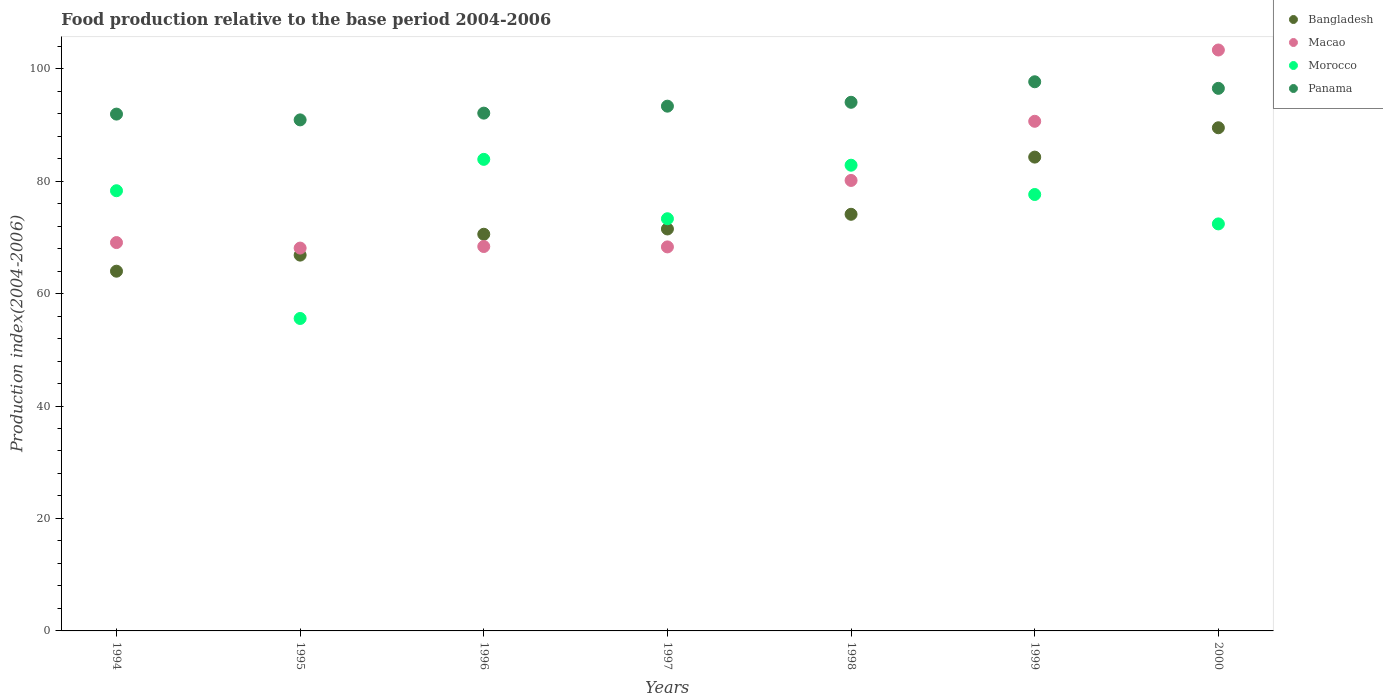What is the food production index in Panama in 1994?
Keep it short and to the point. 91.92. Across all years, what is the maximum food production index in Bangladesh?
Make the answer very short. 89.49. Across all years, what is the minimum food production index in Bangladesh?
Your answer should be compact. 63.98. In which year was the food production index in Morocco minimum?
Ensure brevity in your answer.  1995. What is the total food production index in Bangladesh in the graph?
Your response must be concise. 520.72. What is the difference between the food production index in Bangladesh in 1994 and that in 1997?
Keep it short and to the point. -7.51. What is the difference between the food production index in Bangladesh in 1998 and the food production index in Morocco in 1996?
Keep it short and to the point. -9.77. What is the average food production index in Morocco per year?
Make the answer very short. 74.84. In the year 1998, what is the difference between the food production index in Morocco and food production index in Bangladesh?
Ensure brevity in your answer.  8.73. What is the ratio of the food production index in Macao in 1996 to that in 1999?
Offer a very short reply. 0.75. Is the difference between the food production index in Morocco in 1998 and 1999 greater than the difference between the food production index in Bangladesh in 1998 and 1999?
Your answer should be compact. Yes. What is the difference between the highest and the second highest food production index in Bangladesh?
Ensure brevity in your answer.  5.22. What is the difference between the highest and the lowest food production index in Bangladesh?
Make the answer very short. 25.51. In how many years, is the food production index in Macao greater than the average food production index in Macao taken over all years?
Give a very brief answer. 3. Is the sum of the food production index in Panama in 1997 and 1999 greater than the maximum food production index in Morocco across all years?
Provide a succinct answer. Yes. Is it the case that in every year, the sum of the food production index in Bangladesh and food production index in Panama  is greater than the sum of food production index in Morocco and food production index in Macao?
Offer a terse response. No. Is the food production index in Morocco strictly greater than the food production index in Macao over the years?
Give a very brief answer. No. How many dotlines are there?
Provide a short and direct response. 4. What is the difference between two consecutive major ticks on the Y-axis?
Keep it short and to the point. 20. Does the graph contain any zero values?
Your answer should be compact. No. Does the graph contain grids?
Ensure brevity in your answer.  No. How are the legend labels stacked?
Make the answer very short. Vertical. What is the title of the graph?
Your answer should be compact. Food production relative to the base period 2004-2006. Does "Iceland" appear as one of the legend labels in the graph?
Give a very brief answer. No. What is the label or title of the Y-axis?
Ensure brevity in your answer.  Production index(2004-2006). What is the Production index(2004-2006) in Bangladesh in 1994?
Offer a very short reply. 63.98. What is the Production index(2004-2006) in Macao in 1994?
Offer a very short reply. 69.07. What is the Production index(2004-2006) in Morocco in 1994?
Provide a short and direct response. 78.29. What is the Production index(2004-2006) in Panama in 1994?
Provide a succinct answer. 91.92. What is the Production index(2004-2006) of Bangladesh in 1995?
Offer a terse response. 66.84. What is the Production index(2004-2006) of Macao in 1995?
Offer a terse response. 68.09. What is the Production index(2004-2006) in Morocco in 1995?
Your answer should be very brief. 55.57. What is the Production index(2004-2006) of Panama in 1995?
Ensure brevity in your answer.  90.89. What is the Production index(2004-2006) of Bangladesh in 1996?
Give a very brief answer. 70.55. What is the Production index(2004-2006) in Macao in 1996?
Keep it short and to the point. 68.37. What is the Production index(2004-2006) of Morocco in 1996?
Ensure brevity in your answer.  83.87. What is the Production index(2004-2006) of Panama in 1996?
Give a very brief answer. 92.09. What is the Production index(2004-2006) of Bangladesh in 1997?
Your answer should be compact. 71.49. What is the Production index(2004-2006) of Macao in 1997?
Your response must be concise. 68.3. What is the Production index(2004-2006) of Morocco in 1997?
Provide a succinct answer. 73.31. What is the Production index(2004-2006) in Panama in 1997?
Offer a terse response. 93.33. What is the Production index(2004-2006) in Bangladesh in 1998?
Make the answer very short. 74.1. What is the Production index(2004-2006) of Macao in 1998?
Offer a very short reply. 80.12. What is the Production index(2004-2006) in Morocco in 1998?
Provide a succinct answer. 82.83. What is the Production index(2004-2006) in Panama in 1998?
Your answer should be very brief. 94.02. What is the Production index(2004-2006) in Bangladesh in 1999?
Offer a terse response. 84.27. What is the Production index(2004-2006) of Macao in 1999?
Provide a succinct answer. 90.64. What is the Production index(2004-2006) of Morocco in 1999?
Keep it short and to the point. 77.62. What is the Production index(2004-2006) in Panama in 1999?
Offer a very short reply. 97.67. What is the Production index(2004-2006) of Bangladesh in 2000?
Offer a terse response. 89.49. What is the Production index(2004-2006) in Macao in 2000?
Your answer should be very brief. 103.32. What is the Production index(2004-2006) in Morocco in 2000?
Keep it short and to the point. 72.39. What is the Production index(2004-2006) in Panama in 2000?
Keep it short and to the point. 96.5. Across all years, what is the maximum Production index(2004-2006) of Bangladesh?
Keep it short and to the point. 89.49. Across all years, what is the maximum Production index(2004-2006) of Macao?
Provide a short and direct response. 103.32. Across all years, what is the maximum Production index(2004-2006) of Morocco?
Provide a short and direct response. 83.87. Across all years, what is the maximum Production index(2004-2006) of Panama?
Offer a terse response. 97.67. Across all years, what is the minimum Production index(2004-2006) in Bangladesh?
Offer a very short reply. 63.98. Across all years, what is the minimum Production index(2004-2006) in Macao?
Your answer should be compact. 68.09. Across all years, what is the minimum Production index(2004-2006) in Morocco?
Offer a terse response. 55.57. Across all years, what is the minimum Production index(2004-2006) of Panama?
Provide a succinct answer. 90.89. What is the total Production index(2004-2006) in Bangladesh in the graph?
Keep it short and to the point. 520.72. What is the total Production index(2004-2006) of Macao in the graph?
Your answer should be compact. 547.91. What is the total Production index(2004-2006) of Morocco in the graph?
Provide a short and direct response. 523.88. What is the total Production index(2004-2006) of Panama in the graph?
Your response must be concise. 656.42. What is the difference between the Production index(2004-2006) in Bangladesh in 1994 and that in 1995?
Your answer should be compact. -2.86. What is the difference between the Production index(2004-2006) of Macao in 1994 and that in 1995?
Offer a terse response. 0.98. What is the difference between the Production index(2004-2006) in Morocco in 1994 and that in 1995?
Offer a terse response. 22.72. What is the difference between the Production index(2004-2006) of Panama in 1994 and that in 1995?
Keep it short and to the point. 1.03. What is the difference between the Production index(2004-2006) of Bangladesh in 1994 and that in 1996?
Offer a terse response. -6.57. What is the difference between the Production index(2004-2006) in Macao in 1994 and that in 1996?
Make the answer very short. 0.7. What is the difference between the Production index(2004-2006) in Morocco in 1994 and that in 1996?
Your response must be concise. -5.58. What is the difference between the Production index(2004-2006) of Panama in 1994 and that in 1996?
Your response must be concise. -0.17. What is the difference between the Production index(2004-2006) of Bangladesh in 1994 and that in 1997?
Give a very brief answer. -7.51. What is the difference between the Production index(2004-2006) in Macao in 1994 and that in 1997?
Provide a short and direct response. 0.77. What is the difference between the Production index(2004-2006) of Morocco in 1994 and that in 1997?
Give a very brief answer. 4.98. What is the difference between the Production index(2004-2006) of Panama in 1994 and that in 1997?
Keep it short and to the point. -1.41. What is the difference between the Production index(2004-2006) of Bangladesh in 1994 and that in 1998?
Offer a very short reply. -10.12. What is the difference between the Production index(2004-2006) of Macao in 1994 and that in 1998?
Make the answer very short. -11.05. What is the difference between the Production index(2004-2006) in Morocco in 1994 and that in 1998?
Provide a short and direct response. -4.54. What is the difference between the Production index(2004-2006) in Bangladesh in 1994 and that in 1999?
Your answer should be very brief. -20.29. What is the difference between the Production index(2004-2006) of Macao in 1994 and that in 1999?
Make the answer very short. -21.57. What is the difference between the Production index(2004-2006) of Morocco in 1994 and that in 1999?
Your response must be concise. 0.67. What is the difference between the Production index(2004-2006) of Panama in 1994 and that in 1999?
Provide a succinct answer. -5.75. What is the difference between the Production index(2004-2006) of Bangladesh in 1994 and that in 2000?
Your answer should be very brief. -25.51. What is the difference between the Production index(2004-2006) of Macao in 1994 and that in 2000?
Give a very brief answer. -34.25. What is the difference between the Production index(2004-2006) of Panama in 1994 and that in 2000?
Your response must be concise. -4.58. What is the difference between the Production index(2004-2006) in Bangladesh in 1995 and that in 1996?
Your response must be concise. -3.71. What is the difference between the Production index(2004-2006) in Macao in 1995 and that in 1996?
Give a very brief answer. -0.28. What is the difference between the Production index(2004-2006) of Morocco in 1995 and that in 1996?
Offer a very short reply. -28.3. What is the difference between the Production index(2004-2006) of Panama in 1995 and that in 1996?
Provide a succinct answer. -1.2. What is the difference between the Production index(2004-2006) in Bangladesh in 1995 and that in 1997?
Keep it short and to the point. -4.65. What is the difference between the Production index(2004-2006) in Macao in 1995 and that in 1997?
Keep it short and to the point. -0.21. What is the difference between the Production index(2004-2006) in Morocco in 1995 and that in 1997?
Keep it short and to the point. -17.74. What is the difference between the Production index(2004-2006) of Panama in 1995 and that in 1997?
Provide a succinct answer. -2.44. What is the difference between the Production index(2004-2006) of Bangladesh in 1995 and that in 1998?
Offer a very short reply. -7.26. What is the difference between the Production index(2004-2006) in Macao in 1995 and that in 1998?
Provide a succinct answer. -12.03. What is the difference between the Production index(2004-2006) in Morocco in 1995 and that in 1998?
Your answer should be compact. -27.26. What is the difference between the Production index(2004-2006) of Panama in 1995 and that in 1998?
Your answer should be very brief. -3.13. What is the difference between the Production index(2004-2006) of Bangladesh in 1995 and that in 1999?
Ensure brevity in your answer.  -17.43. What is the difference between the Production index(2004-2006) of Macao in 1995 and that in 1999?
Your answer should be compact. -22.55. What is the difference between the Production index(2004-2006) of Morocco in 1995 and that in 1999?
Provide a short and direct response. -22.05. What is the difference between the Production index(2004-2006) in Panama in 1995 and that in 1999?
Provide a short and direct response. -6.78. What is the difference between the Production index(2004-2006) in Bangladesh in 1995 and that in 2000?
Ensure brevity in your answer.  -22.65. What is the difference between the Production index(2004-2006) of Macao in 1995 and that in 2000?
Your answer should be very brief. -35.23. What is the difference between the Production index(2004-2006) in Morocco in 1995 and that in 2000?
Offer a very short reply. -16.82. What is the difference between the Production index(2004-2006) in Panama in 1995 and that in 2000?
Your answer should be very brief. -5.61. What is the difference between the Production index(2004-2006) in Bangladesh in 1996 and that in 1997?
Offer a terse response. -0.94. What is the difference between the Production index(2004-2006) in Macao in 1996 and that in 1997?
Offer a very short reply. 0.07. What is the difference between the Production index(2004-2006) of Morocco in 1996 and that in 1997?
Provide a short and direct response. 10.56. What is the difference between the Production index(2004-2006) in Panama in 1996 and that in 1997?
Give a very brief answer. -1.24. What is the difference between the Production index(2004-2006) of Bangladesh in 1996 and that in 1998?
Give a very brief answer. -3.55. What is the difference between the Production index(2004-2006) in Macao in 1996 and that in 1998?
Ensure brevity in your answer.  -11.75. What is the difference between the Production index(2004-2006) in Morocco in 1996 and that in 1998?
Ensure brevity in your answer.  1.04. What is the difference between the Production index(2004-2006) of Panama in 1996 and that in 1998?
Give a very brief answer. -1.93. What is the difference between the Production index(2004-2006) of Bangladesh in 1996 and that in 1999?
Offer a very short reply. -13.72. What is the difference between the Production index(2004-2006) of Macao in 1996 and that in 1999?
Your answer should be very brief. -22.27. What is the difference between the Production index(2004-2006) in Morocco in 1996 and that in 1999?
Your response must be concise. 6.25. What is the difference between the Production index(2004-2006) of Panama in 1996 and that in 1999?
Ensure brevity in your answer.  -5.58. What is the difference between the Production index(2004-2006) in Bangladesh in 1996 and that in 2000?
Your response must be concise. -18.94. What is the difference between the Production index(2004-2006) of Macao in 1996 and that in 2000?
Offer a terse response. -34.95. What is the difference between the Production index(2004-2006) in Morocco in 1996 and that in 2000?
Keep it short and to the point. 11.48. What is the difference between the Production index(2004-2006) in Panama in 1996 and that in 2000?
Give a very brief answer. -4.41. What is the difference between the Production index(2004-2006) of Bangladesh in 1997 and that in 1998?
Provide a short and direct response. -2.61. What is the difference between the Production index(2004-2006) in Macao in 1997 and that in 1998?
Keep it short and to the point. -11.82. What is the difference between the Production index(2004-2006) of Morocco in 1997 and that in 1998?
Keep it short and to the point. -9.52. What is the difference between the Production index(2004-2006) in Panama in 1997 and that in 1998?
Ensure brevity in your answer.  -0.69. What is the difference between the Production index(2004-2006) in Bangladesh in 1997 and that in 1999?
Offer a very short reply. -12.78. What is the difference between the Production index(2004-2006) of Macao in 1997 and that in 1999?
Your response must be concise. -22.34. What is the difference between the Production index(2004-2006) in Morocco in 1997 and that in 1999?
Offer a terse response. -4.31. What is the difference between the Production index(2004-2006) in Panama in 1997 and that in 1999?
Offer a terse response. -4.34. What is the difference between the Production index(2004-2006) in Macao in 1997 and that in 2000?
Your answer should be compact. -35.02. What is the difference between the Production index(2004-2006) of Morocco in 1997 and that in 2000?
Your answer should be compact. 0.92. What is the difference between the Production index(2004-2006) of Panama in 1997 and that in 2000?
Offer a very short reply. -3.17. What is the difference between the Production index(2004-2006) in Bangladesh in 1998 and that in 1999?
Keep it short and to the point. -10.17. What is the difference between the Production index(2004-2006) of Macao in 1998 and that in 1999?
Give a very brief answer. -10.52. What is the difference between the Production index(2004-2006) of Morocco in 1998 and that in 1999?
Make the answer very short. 5.21. What is the difference between the Production index(2004-2006) in Panama in 1998 and that in 1999?
Provide a short and direct response. -3.65. What is the difference between the Production index(2004-2006) in Bangladesh in 1998 and that in 2000?
Keep it short and to the point. -15.39. What is the difference between the Production index(2004-2006) in Macao in 1998 and that in 2000?
Keep it short and to the point. -23.2. What is the difference between the Production index(2004-2006) of Morocco in 1998 and that in 2000?
Your response must be concise. 10.44. What is the difference between the Production index(2004-2006) in Panama in 1998 and that in 2000?
Offer a terse response. -2.48. What is the difference between the Production index(2004-2006) in Bangladesh in 1999 and that in 2000?
Provide a short and direct response. -5.22. What is the difference between the Production index(2004-2006) of Macao in 1999 and that in 2000?
Provide a succinct answer. -12.68. What is the difference between the Production index(2004-2006) in Morocco in 1999 and that in 2000?
Provide a succinct answer. 5.23. What is the difference between the Production index(2004-2006) of Panama in 1999 and that in 2000?
Your answer should be compact. 1.17. What is the difference between the Production index(2004-2006) of Bangladesh in 1994 and the Production index(2004-2006) of Macao in 1995?
Make the answer very short. -4.11. What is the difference between the Production index(2004-2006) of Bangladesh in 1994 and the Production index(2004-2006) of Morocco in 1995?
Your answer should be compact. 8.41. What is the difference between the Production index(2004-2006) in Bangladesh in 1994 and the Production index(2004-2006) in Panama in 1995?
Keep it short and to the point. -26.91. What is the difference between the Production index(2004-2006) in Macao in 1994 and the Production index(2004-2006) in Morocco in 1995?
Give a very brief answer. 13.5. What is the difference between the Production index(2004-2006) in Macao in 1994 and the Production index(2004-2006) in Panama in 1995?
Offer a terse response. -21.82. What is the difference between the Production index(2004-2006) in Morocco in 1994 and the Production index(2004-2006) in Panama in 1995?
Offer a very short reply. -12.6. What is the difference between the Production index(2004-2006) in Bangladesh in 1994 and the Production index(2004-2006) in Macao in 1996?
Give a very brief answer. -4.39. What is the difference between the Production index(2004-2006) in Bangladesh in 1994 and the Production index(2004-2006) in Morocco in 1996?
Make the answer very short. -19.89. What is the difference between the Production index(2004-2006) in Bangladesh in 1994 and the Production index(2004-2006) in Panama in 1996?
Your response must be concise. -28.11. What is the difference between the Production index(2004-2006) of Macao in 1994 and the Production index(2004-2006) of Morocco in 1996?
Your answer should be very brief. -14.8. What is the difference between the Production index(2004-2006) in Macao in 1994 and the Production index(2004-2006) in Panama in 1996?
Your answer should be very brief. -23.02. What is the difference between the Production index(2004-2006) in Morocco in 1994 and the Production index(2004-2006) in Panama in 1996?
Give a very brief answer. -13.8. What is the difference between the Production index(2004-2006) of Bangladesh in 1994 and the Production index(2004-2006) of Macao in 1997?
Offer a very short reply. -4.32. What is the difference between the Production index(2004-2006) of Bangladesh in 1994 and the Production index(2004-2006) of Morocco in 1997?
Your answer should be compact. -9.33. What is the difference between the Production index(2004-2006) of Bangladesh in 1994 and the Production index(2004-2006) of Panama in 1997?
Your response must be concise. -29.35. What is the difference between the Production index(2004-2006) of Macao in 1994 and the Production index(2004-2006) of Morocco in 1997?
Ensure brevity in your answer.  -4.24. What is the difference between the Production index(2004-2006) in Macao in 1994 and the Production index(2004-2006) in Panama in 1997?
Provide a succinct answer. -24.26. What is the difference between the Production index(2004-2006) in Morocco in 1994 and the Production index(2004-2006) in Panama in 1997?
Provide a short and direct response. -15.04. What is the difference between the Production index(2004-2006) in Bangladesh in 1994 and the Production index(2004-2006) in Macao in 1998?
Your answer should be compact. -16.14. What is the difference between the Production index(2004-2006) of Bangladesh in 1994 and the Production index(2004-2006) of Morocco in 1998?
Make the answer very short. -18.85. What is the difference between the Production index(2004-2006) of Bangladesh in 1994 and the Production index(2004-2006) of Panama in 1998?
Provide a succinct answer. -30.04. What is the difference between the Production index(2004-2006) in Macao in 1994 and the Production index(2004-2006) in Morocco in 1998?
Offer a very short reply. -13.76. What is the difference between the Production index(2004-2006) of Macao in 1994 and the Production index(2004-2006) of Panama in 1998?
Provide a short and direct response. -24.95. What is the difference between the Production index(2004-2006) of Morocco in 1994 and the Production index(2004-2006) of Panama in 1998?
Your response must be concise. -15.73. What is the difference between the Production index(2004-2006) of Bangladesh in 1994 and the Production index(2004-2006) of Macao in 1999?
Keep it short and to the point. -26.66. What is the difference between the Production index(2004-2006) in Bangladesh in 1994 and the Production index(2004-2006) in Morocco in 1999?
Your answer should be compact. -13.64. What is the difference between the Production index(2004-2006) in Bangladesh in 1994 and the Production index(2004-2006) in Panama in 1999?
Give a very brief answer. -33.69. What is the difference between the Production index(2004-2006) in Macao in 1994 and the Production index(2004-2006) in Morocco in 1999?
Ensure brevity in your answer.  -8.55. What is the difference between the Production index(2004-2006) of Macao in 1994 and the Production index(2004-2006) of Panama in 1999?
Give a very brief answer. -28.6. What is the difference between the Production index(2004-2006) of Morocco in 1994 and the Production index(2004-2006) of Panama in 1999?
Ensure brevity in your answer.  -19.38. What is the difference between the Production index(2004-2006) in Bangladesh in 1994 and the Production index(2004-2006) in Macao in 2000?
Offer a terse response. -39.34. What is the difference between the Production index(2004-2006) of Bangladesh in 1994 and the Production index(2004-2006) of Morocco in 2000?
Give a very brief answer. -8.41. What is the difference between the Production index(2004-2006) in Bangladesh in 1994 and the Production index(2004-2006) in Panama in 2000?
Make the answer very short. -32.52. What is the difference between the Production index(2004-2006) in Macao in 1994 and the Production index(2004-2006) in Morocco in 2000?
Offer a terse response. -3.32. What is the difference between the Production index(2004-2006) of Macao in 1994 and the Production index(2004-2006) of Panama in 2000?
Provide a short and direct response. -27.43. What is the difference between the Production index(2004-2006) in Morocco in 1994 and the Production index(2004-2006) in Panama in 2000?
Make the answer very short. -18.21. What is the difference between the Production index(2004-2006) in Bangladesh in 1995 and the Production index(2004-2006) in Macao in 1996?
Provide a short and direct response. -1.53. What is the difference between the Production index(2004-2006) of Bangladesh in 1995 and the Production index(2004-2006) of Morocco in 1996?
Your response must be concise. -17.03. What is the difference between the Production index(2004-2006) of Bangladesh in 1995 and the Production index(2004-2006) of Panama in 1996?
Give a very brief answer. -25.25. What is the difference between the Production index(2004-2006) of Macao in 1995 and the Production index(2004-2006) of Morocco in 1996?
Offer a very short reply. -15.78. What is the difference between the Production index(2004-2006) in Macao in 1995 and the Production index(2004-2006) in Panama in 1996?
Provide a succinct answer. -24. What is the difference between the Production index(2004-2006) of Morocco in 1995 and the Production index(2004-2006) of Panama in 1996?
Your response must be concise. -36.52. What is the difference between the Production index(2004-2006) in Bangladesh in 1995 and the Production index(2004-2006) in Macao in 1997?
Your answer should be very brief. -1.46. What is the difference between the Production index(2004-2006) of Bangladesh in 1995 and the Production index(2004-2006) of Morocco in 1997?
Your response must be concise. -6.47. What is the difference between the Production index(2004-2006) of Bangladesh in 1995 and the Production index(2004-2006) of Panama in 1997?
Provide a succinct answer. -26.49. What is the difference between the Production index(2004-2006) of Macao in 1995 and the Production index(2004-2006) of Morocco in 1997?
Make the answer very short. -5.22. What is the difference between the Production index(2004-2006) in Macao in 1995 and the Production index(2004-2006) in Panama in 1997?
Your response must be concise. -25.24. What is the difference between the Production index(2004-2006) in Morocco in 1995 and the Production index(2004-2006) in Panama in 1997?
Offer a very short reply. -37.76. What is the difference between the Production index(2004-2006) in Bangladesh in 1995 and the Production index(2004-2006) in Macao in 1998?
Make the answer very short. -13.28. What is the difference between the Production index(2004-2006) in Bangladesh in 1995 and the Production index(2004-2006) in Morocco in 1998?
Your answer should be compact. -15.99. What is the difference between the Production index(2004-2006) of Bangladesh in 1995 and the Production index(2004-2006) of Panama in 1998?
Make the answer very short. -27.18. What is the difference between the Production index(2004-2006) of Macao in 1995 and the Production index(2004-2006) of Morocco in 1998?
Offer a very short reply. -14.74. What is the difference between the Production index(2004-2006) of Macao in 1995 and the Production index(2004-2006) of Panama in 1998?
Offer a very short reply. -25.93. What is the difference between the Production index(2004-2006) of Morocco in 1995 and the Production index(2004-2006) of Panama in 1998?
Your response must be concise. -38.45. What is the difference between the Production index(2004-2006) in Bangladesh in 1995 and the Production index(2004-2006) in Macao in 1999?
Give a very brief answer. -23.8. What is the difference between the Production index(2004-2006) of Bangladesh in 1995 and the Production index(2004-2006) of Morocco in 1999?
Provide a succinct answer. -10.78. What is the difference between the Production index(2004-2006) of Bangladesh in 1995 and the Production index(2004-2006) of Panama in 1999?
Make the answer very short. -30.83. What is the difference between the Production index(2004-2006) in Macao in 1995 and the Production index(2004-2006) in Morocco in 1999?
Offer a very short reply. -9.53. What is the difference between the Production index(2004-2006) of Macao in 1995 and the Production index(2004-2006) of Panama in 1999?
Your answer should be compact. -29.58. What is the difference between the Production index(2004-2006) in Morocco in 1995 and the Production index(2004-2006) in Panama in 1999?
Give a very brief answer. -42.1. What is the difference between the Production index(2004-2006) in Bangladesh in 1995 and the Production index(2004-2006) in Macao in 2000?
Your answer should be very brief. -36.48. What is the difference between the Production index(2004-2006) of Bangladesh in 1995 and the Production index(2004-2006) of Morocco in 2000?
Your answer should be compact. -5.55. What is the difference between the Production index(2004-2006) of Bangladesh in 1995 and the Production index(2004-2006) of Panama in 2000?
Offer a terse response. -29.66. What is the difference between the Production index(2004-2006) in Macao in 1995 and the Production index(2004-2006) in Morocco in 2000?
Your response must be concise. -4.3. What is the difference between the Production index(2004-2006) in Macao in 1995 and the Production index(2004-2006) in Panama in 2000?
Provide a short and direct response. -28.41. What is the difference between the Production index(2004-2006) in Morocco in 1995 and the Production index(2004-2006) in Panama in 2000?
Ensure brevity in your answer.  -40.93. What is the difference between the Production index(2004-2006) of Bangladesh in 1996 and the Production index(2004-2006) of Macao in 1997?
Offer a very short reply. 2.25. What is the difference between the Production index(2004-2006) in Bangladesh in 1996 and the Production index(2004-2006) in Morocco in 1997?
Make the answer very short. -2.76. What is the difference between the Production index(2004-2006) of Bangladesh in 1996 and the Production index(2004-2006) of Panama in 1997?
Make the answer very short. -22.78. What is the difference between the Production index(2004-2006) of Macao in 1996 and the Production index(2004-2006) of Morocco in 1997?
Ensure brevity in your answer.  -4.94. What is the difference between the Production index(2004-2006) of Macao in 1996 and the Production index(2004-2006) of Panama in 1997?
Keep it short and to the point. -24.96. What is the difference between the Production index(2004-2006) of Morocco in 1996 and the Production index(2004-2006) of Panama in 1997?
Make the answer very short. -9.46. What is the difference between the Production index(2004-2006) of Bangladesh in 1996 and the Production index(2004-2006) of Macao in 1998?
Give a very brief answer. -9.57. What is the difference between the Production index(2004-2006) of Bangladesh in 1996 and the Production index(2004-2006) of Morocco in 1998?
Ensure brevity in your answer.  -12.28. What is the difference between the Production index(2004-2006) in Bangladesh in 1996 and the Production index(2004-2006) in Panama in 1998?
Ensure brevity in your answer.  -23.47. What is the difference between the Production index(2004-2006) of Macao in 1996 and the Production index(2004-2006) of Morocco in 1998?
Ensure brevity in your answer.  -14.46. What is the difference between the Production index(2004-2006) in Macao in 1996 and the Production index(2004-2006) in Panama in 1998?
Ensure brevity in your answer.  -25.65. What is the difference between the Production index(2004-2006) of Morocco in 1996 and the Production index(2004-2006) of Panama in 1998?
Keep it short and to the point. -10.15. What is the difference between the Production index(2004-2006) of Bangladesh in 1996 and the Production index(2004-2006) of Macao in 1999?
Provide a succinct answer. -20.09. What is the difference between the Production index(2004-2006) in Bangladesh in 1996 and the Production index(2004-2006) in Morocco in 1999?
Your answer should be very brief. -7.07. What is the difference between the Production index(2004-2006) of Bangladesh in 1996 and the Production index(2004-2006) of Panama in 1999?
Ensure brevity in your answer.  -27.12. What is the difference between the Production index(2004-2006) in Macao in 1996 and the Production index(2004-2006) in Morocco in 1999?
Provide a succinct answer. -9.25. What is the difference between the Production index(2004-2006) in Macao in 1996 and the Production index(2004-2006) in Panama in 1999?
Provide a short and direct response. -29.3. What is the difference between the Production index(2004-2006) of Bangladesh in 1996 and the Production index(2004-2006) of Macao in 2000?
Provide a short and direct response. -32.77. What is the difference between the Production index(2004-2006) of Bangladesh in 1996 and the Production index(2004-2006) of Morocco in 2000?
Give a very brief answer. -1.84. What is the difference between the Production index(2004-2006) of Bangladesh in 1996 and the Production index(2004-2006) of Panama in 2000?
Make the answer very short. -25.95. What is the difference between the Production index(2004-2006) in Macao in 1996 and the Production index(2004-2006) in Morocco in 2000?
Keep it short and to the point. -4.02. What is the difference between the Production index(2004-2006) in Macao in 1996 and the Production index(2004-2006) in Panama in 2000?
Your answer should be very brief. -28.13. What is the difference between the Production index(2004-2006) in Morocco in 1996 and the Production index(2004-2006) in Panama in 2000?
Provide a succinct answer. -12.63. What is the difference between the Production index(2004-2006) in Bangladesh in 1997 and the Production index(2004-2006) in Macao in 1998?
Your response must be concise. -8.63. What is the difference between the Production index(2004-2006) of Bangladesh in 1997 and the Production index(2004-2006) of Morocco in 1998?
Provide a short and direct response. -11.34. What is the difference between the Production index(2004-2006) of Bangladesh in 1997 and the Production index(2004-2006) of Panama in 1998?
Offer a very short reply. -22.53. What is the difference between the Production index(2004-2006) of Macao in 1997 and the Production index(2004-2006) of Morocco in 1998?
Keep it short and to the point. -14.53. What is the difference between the Production index(2004-2006) in Macao in 1997 and the Production index(2004-2006) in Panama in 1998?
Provide a succinct answer. -25.72. What is the difference between the Production index(2004-2006) of Morocco in 1997 and the Production index(2004-2006) of Panama in 1998?
Provide a short and direct response. -20.71. What is the difference between the Production index(2004-2006) in Bangladesh in 1997 and the Production index(2004-2006) in Macao in 1999?
Your response must be concise. -19.15. What is the difference between the Production index(2004-2006) of Bangladesh in 1997 and the Production index(2004-2006) of Morocco in 1999?
Give a very brief answer. -6.13. What is the difference between the Production index(2004-2006) of Bangladesh in 1997 and the Production index(2004-2006) of Panama in 1999?
Your response must be concise. -26.18. What is the difference between the Production index(2004-2006) in Macao in 1997 and the Production index(2004-2006) in Morocco in 1999?
Provide a succinct answer. -9.32. What is the difference between the Production index(2004-2006) in Macao in 1997 and the Production index(2004-2006) in Panama in 1999?
Your response must be concise. -29.37. What is the difference between the Production index(2004-2006) of Morocco in 1997 and the Production index(2004-2006) of Panama in 1999?
Provide a succinct answer. -24.36. What is the difference between the Production index(2004-2006) of Bangladesh in 1997 and the Production index(2004-2006) of Macao in 2000?
Provide a short and direct response. -31.83. What is the difference between the Production index(2004-2006) of Bangladesh in 1997 and the Production index(2004-2006) of Morocco in 2000?
Provide a short and direct response. -0.9. What is the difference between the Production index(2004-2006) in Bangladesh in 1997 and the Production index(2004-2006) in Panama in 2000?
Ensure brevity in your answer.  -25.01. What is the difference between the Production index(2004-2006) in Macao in 1997 and the Production index(2004-2006) in Morocco in 2000?
Offer a very short reply. -4.09. What is the difference between the Production index(2004-2006) in Macao in 1997 and the Production index(2004-2006) in Panama in 2000?
Ensure brevity in your answer.  -28.2. What is the difference between the Production index(2004-2006) of Morocco in 1997 and the Production index(2004-2006) of Panama in 2000?
Give a very brief answer. -23.19. What is the difference between the Production index(2004-2006) in Bangladesh in 1998 and the Production index(2004-2006) in Macao in 1999?
Keep it short and to the point. -16.54. What is the difference between the Production index(2004-2006) of Bangladesh in 1998 and the Production index(2004-2006) of Morocco in 1999?
Give a very brief answer. -3.52. What is the difference between the Production index(2004-2006) of Bangladesh in 1998 and the Production index(2004-2006) of Panama in 1999?
Make the answer very short. -23.57. What is the difference between the Production index(2004-2006) of Macao in 1998 and the Production index(2004-2006) of Panama in 1999?
Provide a short and direct response. -17.55. What is the difference between the Production index(2004-2006) in Morocco in 1998 and the Production index(2004-2006) in Panama in 1999?
Your answer should be very brief. -14.84. What is the difference between the Production index(2004-2006) of Bangladesh in 1998 and the Production index(2004-2006) of Macao in 2000?
Your answer should be compact. -29.22. What is the difference between the Production index(2004-2006) in Bangladesh in 1998 and the Production index(2004-2006) in Morocco in 2000?
Provide a short and direct response. 1.71. What is the difference between the Production index(2004-2006) in Bangladesh in 1998 and the Production index(2004-2006) in Panama in 2000?
Make the answer very short. -22.4. What is the difference between the Production index(2004-2006) in Macao in 1998 and the Production index(2004-2006) in Morocco in 2000?
Your response must be concise. 7.73. What is the difference between the Production index(2004-2006) in Macao in 1998 and the Production index(2004-2006) in Panama in 2000?
Your answer should be very brief. -16.38. What is the difference between the Production index(2004-2006) in Morocco in 1998 and the Production index(2004-2006) in Panama in 2000?
Provide a succinct answer. -13.67. What is the difference between the Production index(2004-2006) of Bangladesh in 1999 and the Production index(2004-2006) of Macao in 2000?
Your answer should be compact. -19.05. What is the difference between the Production index(2004-2006) in Bangladesh in 1999 and the Production index(2004-2006) in Morocco in 2000?
Offer a terse response. 11.88. What is the difference between the Production index(2004-2006) of Bangladesh in 1999 and the Production index(2004-2006) of Panama in 2000?
Your response must be concise. -12.23. What is the difference between the Production index(2004-2006) in Macao in 1999 and the Production index(2004-2006) in Morocco in 2000?
Your answer should be compact. 18.25. What is the difference between the Production index(2004-2006) of Macao in 1999 and the Production index(2004-2006) of Panama in 2000?
Offer a terse response. -5.86. What is the difference between the Production index(2004-2006) of Morocco in 1999 and the Production index(2004-2006) of Panama in 2000?
Your response must be concise. -18.88. What is the average Production index(2004-2006) of Bangladesh per year?
Keep it short and to the point. 74.39. What is the average Production index(2004-2006) of Macao per year?
Offer a terse response. 78.27. What is the average Production index(2004-2006) in Morocco per year?
Provide a short and direct response. 74.84. What is the average Production index(2004-2006) of Panama per year?
Make the answer very short. 93.77. In the year 1994, what is the difference between the Production index(2004-2006) of Bangladesh and Production index(2004-2006) of Macao?
Your response must be concise. -5.09. In the year 1994, what is the difference between the Production index(2004-2006) of Bangladesh and Production index(2004-2006) of Morocco?
Your answer should be very brief. -14.31. In the year 1994, what is the difference between the Production index(2004-2006) in Bangladesh and Production index(2004-2006) in Panama?
Your answer should be compact. -27.94. In the year 1994, what is the difference between the Production index(2004-2006) of Macao and Production index(2004-2006) of Morocco?
Make the answer very short. -9.22. In the year 1994, what is the difference between the Production index(2004-2006) in Macao and Production index(2004-2006) in Panama?
Provide a succinct answer. -22.85. In the year 1994, what is the difference between the Production index(2004-2006) in Morocco and Production index(2004-2006) in Panama?
Your response must be concise. -13.63. In the year 1995, what is the difference between the Production index(2004-2006) in Bangladesh and Production index(2004-2006) in Macao?
Offer a very short reply. -1.25. In the year 1995, what is the difference between the Production index(2004-2006) in Bangladesh and Production index(2004-2006) in Morocco?
Give a very brief answer. 11.27. In the year 1995, what is the difference between the Production index(2004-2006) of Bangladesh and Production index(2004-2006) of Panama?
Offer a very short reply. -24.05. In the year 1995, what is the difference between the Production index(2004-2006) of Macao and Production index(2004-2006) of Morocco?
Give a very brief answer. 12.52. In the year 1995, what is the difference between the Production index(2004-2006) in Macao and Production index(2004-2006) in Panama?
Ensure brevity in your answer.  -22.8. In the year 1995, what is the difference between the Production index(2004-2006) of Morocco and Production index(2004-2006) of Panama?
Give a very brief answer. -35.32. In the year 1996, what is the difference between the Production index(2004-2006) in Bangladesh and Production index(2004-2006) in Macao?
Provide a short and direct response. 2.18. In the year 1996, what is the difference between the Production index(2004-2006) of Bangladesh and Production index(2004-2006) of Morocco?
Give a very brief answer. -13.32. In the year 1996, what is the difference between the Production index(2004-2006) of Bangladesh and Production index(2004-2006) of Panama?
Offer a terse response. -21.54. In the year 1996, what is the difference between the Production index(2004-2006) in Macao and Production index(2004-2006) in Morocco?
Give a very brief answer. -15.5. In the year 1996, what is the difference between the Production index(2004-2006) in Macao and Production index(2004-2006) in Panama?
Offer a very short reply. -23.72. In the year 1996, what is the difference between the Production index(2004-2006) in Morocco and Production index(2004-2006) in Panama?
Your response must be concise. -8.22. In the year 1997, what is the difference between the Production index(2004-2006) of Bangladesh and Production index(2004-2006) of Macao?
Offer a very short reply. 3.19. In the year 1997, what is the difference between the Production index(2004-2006) in Bangladesh and Production index(2004-2006) in Morocco?
Your answer should be compact. -1.82. In the year 1997, what is the difference between the Production index(2004-2006) in Bangladesh and Production index(2004-2006) in Panama?
Give a very brief answer. -21.84. In the year 1997, what is the difference between the Production index(2004-2006) of Macao and Production index(2004-2006) of Morocco?
Give a very brief answer. -5.01. In the year 1997, what is the difference between the Production index(2004-2006) of Macao and Production index(2004-2006) of Panama?
Offer a terse response. -25.03. In the year 1997, what is the difference between the Production index(2004-2006) of Morocco and Production index(2004-2006) of Panama?
Provide a short and direct response. -20.02. In the year 1998, what is the difference between the Production index(2004-2006) in Bangladesh and Production index(2004-2006) in Macao?
Make the answer very short. -6.02. In the year 1998, what is the difference between the Production index(2004-2006) of Bangladesh and Production index(2004-2006) of Morocco?
Your answer should be very brief. -8.73. In the year 1998, what is the difference between the Production index(2004-2006) in Bangladesh and Production index(2004-2006) in Panama?
Provide a succinct answer. -19.92. In the year 1998, what is the difference between the Production index(2004-2006) of Macao and Production index(2004-2006) of Morocco?
Give a very brief answer. -2.71. In the year 1998, what is the difference between the Production index(2004-2006) in Macao and Production index(2004-2006) in Panama?
Offer a terse response. -13.9. In the year 1998, what is the difference between the Production index(2004-2006) in Morocco and Production index(2004-2006) in Panama?
Offer a terse response. -11.19. In the year 1999, what is the difference between the Production index(2004-2006) in Bangladesh and Production index(2004-2006) in Macao?
Provide a short and direct response. -6.37. In the year 1999, what is the difference between the Production index(2004-2006) in Bangladesh and Production index(2004-2006) in Morocco?
Give a very brief answer. 6.65. In the year 1999, what is the difference between the Production index(2004-2006) of Bangladesh and Production index(2004-2006) of Panama?
Offer a terse response. -13.4. In the year 1999, what is the difference between the Production index(2004-2006) of Macao and Production index(2004-2006) of Morocco?
Give a very brief answer. 13.02. In the year 1999, what is the difference between the Production index(2004-2006) in Macao and Production index(2004-2006) in Panama?
Offer a very short reply. -7.03. In the year 1999, what is the difference between the Production index(2004-2006) in Morocco and Production index(2004-2006) in Panama?
Provide a succinct answer. -20.05. In the year 2000, what is the difference between the Production index(2004-2006) in Bangladesh and Production index(2004-2006) in Macao?
Your answer should be very brief. -13.83. In the year 2000, what is the difference between the Production index(2004-2006) of Bangladesh and Production index(2004-2006) of Panama?
Offer a terse response. -7.01. In the year 2000, what is the difference between the Production index(2004-2006) in Macao and Production index(2004-2006) in Morocco?
Provide a succinct answer. 30.93. In the year 2000, what is the difference between the Production index(2004-2006) in Macao and Production index(2004-2006) in Panama?
Ensure brevity in your answer.  6.82. In the year 2000, what is the difference between the Production index(2004-2006) of Morocco and Production index(2004-2006) of Panama?
Keep it short and to the point. -24.11. What is the ratio of the Production index(2004-2006) in Bangladesh in 1994 to that in 1995?
Keep it short and to the point. 0.96. What is the ratio of the Production index(2004-2006) of Macao in 1994 to that in 1995?
Your answer should be compact. 1.01. What is the ratio of the Production index(2004-2006) of Morocco in 1994 to that in 1995?
Ensure brevity in your answer.  1.41. What is the ratio of the Production index(2004-2006) in Panama in 1994 to that in 1995?
Offer a terse response. 1.01. What is the ratio of the Production index(2004-2006) in Bangladesh in 1994 to that in 1996?
Your answer should be very brief. 0.91. What is the ratio of the Production index(2004-2006) in Macao in 1994 to that in 1996?
Offer a very short reply. 1.01. What is the ratio of the Production index(2004-2006) in Morocco in 1994 to that in 1996?
Offer a terse response. 0.93. What is the ratio of the Production index(2004-2006) of Panama in 1994 to that in 1996?
Ensure brevity in your answer.  1. What is the ratio of the Production index(2004-2006) of Bangladesh in 1994 to that in 1997?
Ensure brevity in your answer.  0.9. What is the ratio of the Production index(2004-2006) in Macao in 1994 to that in 1997?
Provide a succinct answer. 1.01. What is the ratio of the Production index(2004-2006) of Morocco in 1994 to that in 1997?
Provide a succinct answer. 1.07. What is the ratio of the Production index(2004-2006) of Panama in 1994 to that in 1997?
Offer a terse response. 0.98. What is the ratio of the Production index(2004-2006) of Bangladesh in 1994 to that in 1998?
Provide a succinct answer. 0.86. What is the ratio of the Production index(2004-2006) in Macao in 1994 to that in 1998?
Give a very brief answer. 0.86. What is the ratio of the Production index(2004-2006) of Morocco in 1994 to that in 1998?
Provide a short and direct response. 0.95. What is the ratio of the Production index(2004-2006) of Panama in 1994 to that in 1998?
Your response must be concise. 0.98. What is the ratio of the Production index(2004-2006) of Bangladesh in 1994 to that in 1999?
Your answer should be compact. 0.76. What is the ratio of the Production index(2004-2006) of Macao in 1994 to that in 1999?
Offer a very short reply. 0.76. What is the ratio of the Production index(2004-2006) in Morocco in 1994 to that in 1999?
Provide a succinct answer. 1.01. What is the ratio of the Production index(2004-2006) of Panama in 1994 to that in 1999?
Give a very brief answer. 0.94. What is the ratio of the Production index(2004-2006) in Bangladesh in 1994 to that in 2000?
Offer a very short reply. 0.71. What is the ratio of the Production index(2004-2006) of Macao in 1994 to that in 2000?
Keep it short and to the point. 0.67. What is the ratio of the Production index(2004-2006) of Morocco in 1994 to that in 2000?
Make the answer very short. 1.08. What is the ratio of the Production index(2004-2006) in Panama in 1994 to that in 2000?
Your answer should be very brief. 0.95. What is the ratio of the Production index(2004-2006) of Macao in 1995 to that in 1996?
Provide a short and direct response. 1. What is the ratio of the Production index(2004-2006) in Morocco in 1995 to that in 1996?
Make the answer very short. 0.66. What is the ratio of the Production index(2004-2006) of Bangladesh in 1995 to that in 1997?
Give a very brief answer. 0.94. What is the ratio of the Production index(2004-2006) of Macao in 1995 to that in 1997?
Your answer should be very brief. 1. What is the ratio of the Production index(2004-2006) in Morocco in 1995 to that in 1997?
Provide a succinct answer. 0.76. What is the ratio of the Production index(2004-2006) of Panama in 1995 to that in 1997?
Your answer should be compact. 0.97. What is the ratio of the Production index(2004-2006) of Bangladesh in 1995 to that in 1998?
Ensure brevity in your answer.  0.9. What is the ratio of the Production index(2004-2006) of Macao in 1995 to that in 1998?
Your answer should be very brief. 0.85. What is the ratio of the Production index(2004-2006) in Morocco in 1995 to that in 1998?
Your answer should be very brief. 0.67. What is the ratio of the Production index(2004-2006) in Panama in 1995 to that in 1998?
Your response must be concise. 0.97. What is the ratio of the Production index(2004-2006) of Bangladesh in 1995 to that in 1999?
Give a very brief answer. 0.79. What is the ratio of the Production index(2004-2006) of Macao in 1995 to that in 1999?
Provide a succinct answer. 0.75. What is the ratio of the Production index(2004-2006) of Morocco in 1995 to that in 1999?
Your answer should be compact. 0.72. What is the ratio of the Production index(2004-2006) of Panama in 1995 to that in 1999?
Make the answer very short. 0.93. What is the ratio of the Production index(2004-2006) of Bangladesh in 1995 to that in 2000?
Your answer should be very brief. 0.75. What is the ratio of the Production index(2004-2006) in Macao in 1995 to that in 2000?
Provide a succinct answer. 0.66. What is the ratio of the Production index(2004-2006) of Morocco in 1995 to that in 2000?
Your answer should be compact. 0.77. What is the ratio of the Production index(2004-2006) of Panama in 1995 to that in 2000?
Offer a terse response. 0.94. What is the ratio of the Production index(2004-2006) of Bangladesh in 1996 to that in 1997?
Provide a short and direct response. 0.99. What is the ratio of the Production index(2004-2006) in Morocco in 1996 to that in 1997?
Your response must be concise. 1.14. What is the ratio of the Production index(2004-2006) in Panama in 1996 to that in 1997?
Your response must be concise. 0.99. What is the ratio of the Production index(2004-2006) in Bangladesh in 1996 to that in 1998?
Offer a very short reply. 0.95. What is the ratio of the Production index(2004-2006) of Macao in 1996 to that in 1998?
Provide a short and direct response. 0.85. What is the ratio of the Production index(2004-2006) of Morocco in 1996 to that in 1998?
Offer a terse response. 1.01. What is the ratio of the Production index(2004-2006) of Panama in 1996 to that in 1998?
Offer a very short reply. 0.98. What is the ratio of the Production index(2004-2006) in Bangladesh in 1996 to that in 1999?
Offer a very short reply. 0.84. What is the ratio of the Production index(2004-2006) in Macao in 1996 to that in 1999?
Your answer should be very brief. 0.75. What is the ratio of the Production index(2004-2006) in Morocco in 1996 to that in 1999?
Keep it short and to the point. 1.08. What is the ratio of the Production index(2004-2006) in Panama in 1996 to that in 1999?
Offer a very short reply. 0.94. What is the ratio of the Production index(2004-2006) of Bangladesh in 1996 to that in 2000?
Make the answer very short. 0.79. What is the ratio of the Production index(2004-2006) of Macao in 1996 to that in 2000?
Provide a short and direct response. 0.66. What is the ratio of the Production index(2004-2006) of Morocco in 1996 to that in 2000?
Provide a succinct answer. 1.16. What is the ratio of the Production index(2004-2006) in Panama in 1996 to that in 2000?
Your answer should be very brief. 0.95. What is the ratio of the Production index(2004-2006) of Bangladesh in 1997 to that in 1998?
Make the answer very short. 0.96. What is the ratio of the Production index(2004-2006) of Macao in 1997 to that in 1998?
Your answer should be compact. 0.85. What is the ratio of the Production index(2004-2006) of Morocco in 1997 to that in 1998?
Your answer should be compact. 0.89. What is the ratio of the Production index(2004-2006) of Bangladesh in 1997 to that in 1999?
Your answer should be compact. 0.85. What is the ratio of the Production index(2004-2006) of Macao in 1997 to that in 1999?
Make the answer very short. 0.75. What is the ratio of the Production index(2004-2006) of Morocco in 1997 to that in 1999?
Provide a short and direct response. 0.94. What is the ratio of the Production index(2004-2006) of Panama in 1997 to that in 1999?
Make the answer very short. 0.96. What is the ratio of the Production index(2004-2006) in Bangladesh in 1997 to that in 2000?
Offer a very short reply. 0.8. What is the ratio of the Production index(2004-2006) of Macao in 1997 to that in 2000?
Keep it short and to the point. 0.66. What is the ratio of the Production index(2004-2006) of Morocco in 1997 to that in 2000?
Provide a short and direct response. 1.01. What is the ratio of the Production index(2004-2006) in Panama in 1997 to that in 2000?
Give a very brief answer. 0.97. What is the ratio of the Production index(2004-2006) in Bangladesh in 1998 to that in 1999?
Your response must be concise. 0.88. What is the ratio of the Production index(2004-2006) in Macao in 1998 to that in 1999?
Provide a short and direct response. 0.88. What is the ratio of the Production index(2004-2006) in Morocco in 1998 to that in 1999?
Your answer should be compact. 1.07. What is the ratio of the Production index(2004-2006) in Panama in 1998 to that in 1999?
Give a very brief answer. 0.96. What is the ratio of the Production index(2004-2006) of Bangladesh in 1998 to that in 2000?
Your answer should be very brief. 0.83. What is the ratio of the Production index(2004-2006) in Macao in 1998 to that in 2000?
Provide a succinct answer. 0.78. What is the ratio of the Production index(2004-2006) in Morocco in 1998 to that in 2000?
Make the answer very short. 1.14. What is the ratio of the Production index(2004-2006) of Panama in 1998 to that in 2000?
Provide a short and direct response. 0.97. What is the ratio of the Production index(2004-2006) of Bangladesh in 1999 to that in 2000?
Offer a very short reply. 0.94. What is the ratio of the Production index(2004-2006) in Macao in 1999 to that in 2000?
Provide a short and direct response. 0.88. What is the ratio of the Production index(2004-2006) of Morocco in 1999 to that in 2000?
Offer a terse response. 1.07. What is the ratio of the Production index(2004-2006) in Panama in 1999 to that in 2000?
Provide a short and direct response. 1.01. What is the difference between the highest and the second highest Production index(2004-2006) in Bangladesh?
Offer a very short reply. 5.22. What is the difference between the highest and the second highest Production index(2004-2006) of Macao?
Offer a terse response. 12.68. What is the difference between the highest and the second highest Production index(2004-2006) of Morocco?
Keep it short and to the point. 1.04. What is the difference between the highest and the second highest Production index(2004-2006) of Panama?
Your answer should be compact. 1.17. What is the difference between the highest and the lowest Production index(2004-2006) of Bangladesh?
Offer a very short reply. 25.51. What is the difference between the highest and the lowest Production index(2004-2006) of Macao?
Ensure brevity in your answer.  35.23. What is the difference between the highest and the lowest Production index(2004-2006) of Morocco?
Offer a very short reply. 28.3. What is the difference between the highest and the lowest Production index(2004-2006) of Panama?
Your answer should be compact. 6.78. 